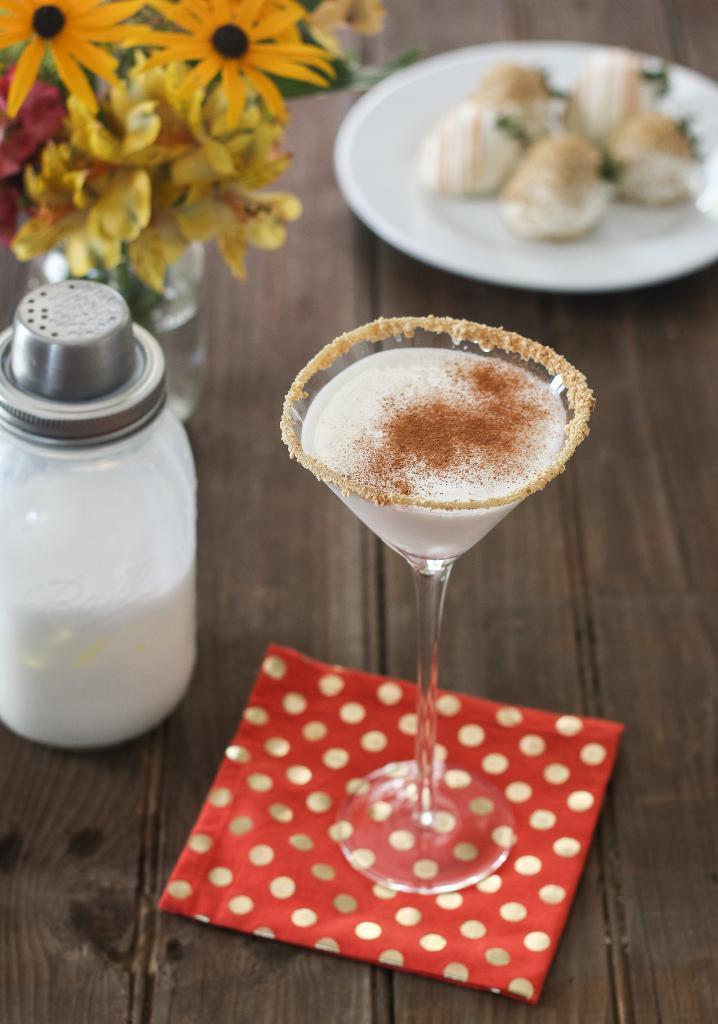In one or two sentences, can you explain what this image depicts? In the picture I can see a wooden table. I can see a plate, a flower vase, a salt bottle and a glass are kept on the wooden table. 